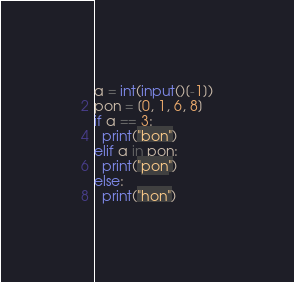Convert code to text. <code><loc_0><loc_0><loc_500><loc_500><_Python_>a = int(input()[-1])
pon = [0, 1, 6, 8]
if a == 3:
  print("bon")
elif a in pon:
  print("pon")
else:
  print("hon")</code> 